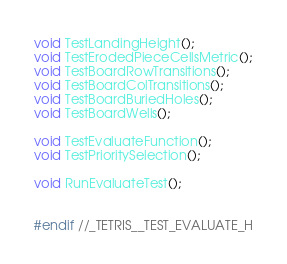Convert code to text. <code><loc_0><loc_0><loc_500><loc_500><_C_>void TestLandingHeight();
void TestErodedPieceCellsMetric();
void TestBoardRowTransitions();
void TestBoardColTransitions();
void TestBoardBuriedHoles();
void TestBoardWells();

void TestEvaluateFunction();
void TestPrioritySelection();

void RunEvaluateTest();


#endif //_TETRIS__TEST_EVALUATE_H
</code> 